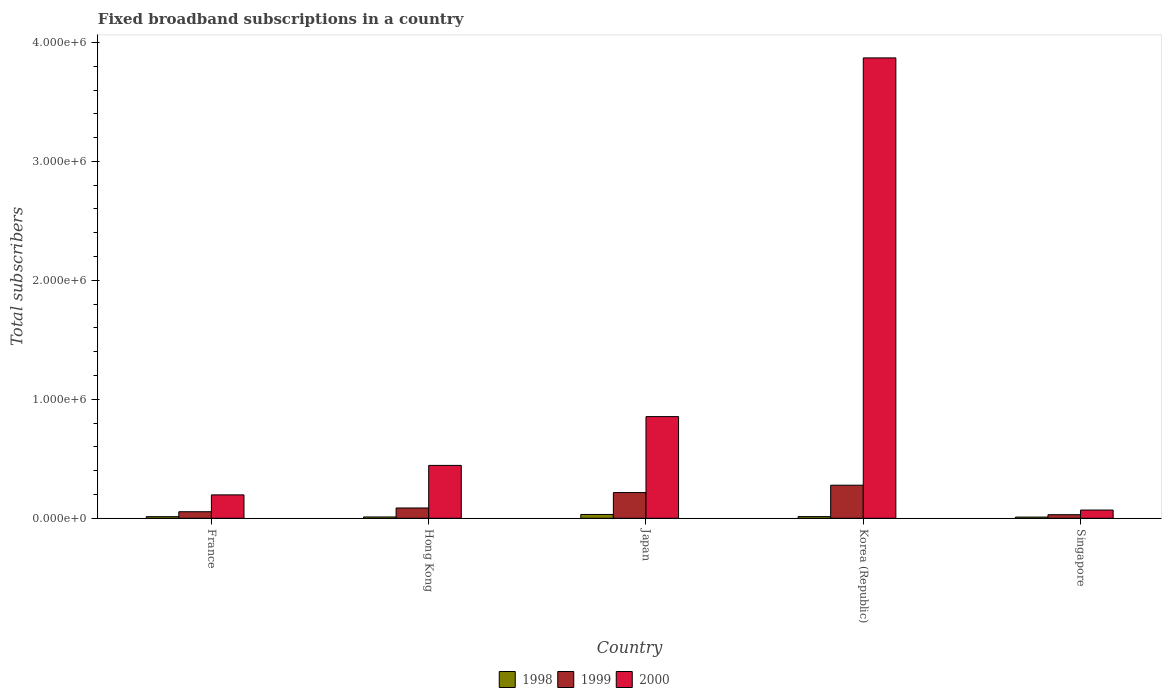How many groups of bars are there?
Keep it short and to the point. 5. In how many cases, is the number of bars for a given country not equal to the number of legend labels?
Offer a very short reply. 0. What is the number of broadband subscriptions in 1999 in France?
Your answer should be very brief. 5.50e+04. Across all countries, what is the maximum number of broadband subscriptions in 1998?
Your response must be concise. 3.20e+04. Across all countries, what is the minimum number of broadband subscriptions in 2000?
Ensure brevity in your answer.  6.90e+04. In which country was the number of broadband subscriptions in 1998 minimum?
Your response must be concise. Singapore. What is the total number of broadband subscriptions in 1999 in the graph?
Your answer should be very brief. 6.65e+05. What is the difference between the number of broadband subscriptions in 2000 in France and that in Singapore?
Provide a short and direct response. 1.28e+05. What is the difference between the number of broadband subscriptions in 2000 in Korea (Republic) and the number of broadband subscriptions in 1999 in Hong Kong?
Your answer should be compact. 3.78e+06. What is the average number of broadband subscriptions in 2000 per country?
Give a very brief answer. 1.09e+06. What is the difference between the number of broadband subscriptions of/in 2000 and number of broadband subscriptions of/in 1999 in Singapore?
Your answer should be very brief. 3.90e+04. What is the ratio of the number of broadband subscriptions in 1999 in Hong Kong to that in Korea (Republic)?
Offer a terse response. 0.31. What is the difference between the highest and the second highest number of broadband subscriptions in 1999?
Offer a very short reply. 1.92e+05. What is the difference between the highest and the lowest number of broadband subscriptions in 1998?
Keep it short and to the point. 2.20e+04. What does the 3rd bar from the left in France represents?
Provide a short and direct response. 2000. How many bars are there?
Offer a terse response. 15. Are all the bars in the graph horizontal?
Give a very brief answer. No. What is the difference between two consecutive major ticks on the Y-axis?
Your answer should be very brief. 1.00e+06. Are the values on the major ticks of Y-axis written in scientific E-notation?
Make the answer very short. Yes. Where does the legend appear in the graph?
Make the answer very short. Bottom center. What is the title of the graph?
Offer a very short reply. Fixed broadband subscriptions in a country. What is the label or title of the X-axis?
Your answer should be very brief. Country. What is the label or title of the Y-axis?
Ensure brevity in your answer.  Total subscribers. What is the Total subscribers of 1998 in France?
Provide a succinct answer. 1.35e+04. What is the Total subscribers in 1999 in France?
Your answer should be compact. 5.50e+04. What is the Total subscribers of 2000 in France?
Keep it short and to the point. 1.97e+05. What is the Total subscribers of 1998 in Hong Kong?
Provide a succinct answer. 1.10e+04. What is the Total subscribers in 1999 in Hong Kong?
Ensure brevity in your answer.  8.65e+04. What is the Total subscribers in 2000 in Hong Kong?
Your response must be concise. 4.44e+05. What is the Total subscribers in 1998 in Japan?
Provide a short and direct response. 3.20e+04. What is the Total subscribers of 1999 in Japan?
Give a very brief answer. 2.16e+05. What is the Total subscribers in 2000 in Japan?
Provide a short and direct response. 8.55e+05. What is the Total subscribers in 1998 in Korea (Republic)?
Offer a very short reply. 1.40e+04. What is the Total subscribers in 1999 in Korea (Republic)?
Give a very brief answer. 2.78e+05. What is the Total subscribers of 2000 in Korea (Republic)?
Make the answer very short. 3.87e+06. What is the Total subscribers of 2000 in Singapore?
Give a very brief answer. 6.90e+04. Across all countries, what is the maximum Total subscribers in 1998?
Ensure brevity in your answer.  3.20e+04. Across all countries, what is the maximum Total subscribers of 1999?
Keep it short and to the point. 2.78e+05. Across all countries, what is the maximum Total subscribers of 2000?
Provide a succinct answer. 3.87e+06. Across all countries, what is the minimum Total subscribers of 2000?
Your response must be concise. 6.90e+04. What is the total Total subscribers of 1998 in the graph?
Offer a terse response. 8.05e+04. What is the total Total subscribers in 1999 in the graph?
Your answer should be very brief. 6.65e+05. What is the total Total subscribers in 2000 in the graph?
Make the answer very short. 5.43e+06. What is the difference between the Total subscribers in 1998 in France and that in Hong Kong?
Provide a short and direct response. 2464. What is the difference between the Total subscribers of 1999 in France and that in Hong Kong?
Provide a succinct answer. -3.15e+04. What is the difference between the Total subscribers in 2000 in France and that in Hong Kong?
Make the answer very short. -2.48e+05. What is the difference between the Total subscribers in 1998 in France and that in Japan?
Your response must be concise. -1.85e+04. What is the difference between the Total subscribers in 1999 in France and that in Japan?
Provide a succinct answer. -1.61e+05. What is the difference between the Total subscribers in 2000 in France and that in Japan?
Provide a succinct answer. -6.58e+05. What is the difference between the Total subscribers of 1998 in France and that in Korea (Republic)?
Give a very brief answer. -536. What is the difference between the Total subscribers of 1999 in France and that in Korea (Republic)?
Your answer should be compact. -2.23e+05. What is the difference between the Total subscribers of 2000 in France and that in Korea (Republic)?
Keep it short and to the point. -3.67e+06. What is the difference between the Total subscribers in 1998 in France and that in Singapore?
Ensure brevity in your answer.  3464. What is the difference between the Total subscribers in 1999 in France and that in Singapore?
Give a very brief answer. 2.50e+04. What is the difference between the Total subscribers of 2000 in France and that in Singapore?
Provide a short and direct response. 1.28e+05. What is the difference between the Total subscribers of 1998 in Hong Kong and that in Japan?
Your answer should be compact. -2.10e+04. What is the difference between the Total subscribers of 1999 in Hong Kong and that in Japan?
Your answer should be compact. -1.30e+05. What is the difference between the Total subscribers of 2000 in Hong Kong and that in Japan?
Your response must be concise. -4.10e+05. What is the difference between the Total subscribers of 1998 in Hong Kong and that in Korea (Republic)?
Your answer should be compact. -3000. What is the difference between the Total subscribers of 1999 in Hong Kong and that in Korea (Republic)?
Your response must be concise. -1.92e+05. What is the difference between the Total subscribers in 2000 in Hong Kong and that in Korea (Republic)?
Provide a short and direct response. -3.43e+06. What is the difference between the Total subscribers in 1999 in Hong Kong and that in Singapore?
Keep it short and to the point. 5.65e+04. What is the difference between the Total subscribers in 2000 in Hong Kong and that in Singapore?
Keep it short and to the point. 3.75e+05. What is the difference between the Total subscribers in 1998 in Japan and that in Korea (Republic)?
Your response must be concise. 1.80e+04. What is the difference between the Total subscribers of 1999 in Japan and that in Korea (Republic)?
Give a very brief answer. -6.20e+04. What is the difference between the Total subscribers in 2000 in Japan and that in Korea (Republic)?
Keep it short and to the point. -3.02e+06. What is the difference between the Total subscribers in 1998 in Japan and that in Singapore?
Your answer should be compact. 2.20e+04. What is the difference between the Total subscribers of 1999 in Japan and that in Singapore?
Your answer should be very brief. 1.86e+05. What is the difference between the Total subscribers in 2000 in Japan and that in Singapore?
Your response must be concise. 7.86e+05. What is the difference between the Total subscribers in 1998 in Korea (Republic) and that in Singapore?
Provide a short and direct response. 4000. What is the difference between the Total subscribers of 1999 in Korea (Republic) and that in Singapore?
Offer a very short reply. 2.48e+05. What is the difference between the Total subscribers of 2000 in Korea (Republic) and that in Singapore?
Make the answer very short. 3.80e+06. What is the difference between the Total subscribers of 1998 in France and the Total subscribers of 1999 in Hong Kong?
Ensure brevity in your answer.  -7.30e+04. What is the difference between the Total subscribers of 1998 in France and the Total subscribers of 2000 in Hong Kong?
Provide a succinct answer. -4.31e+05. What is the difference between the Total subscribers of 1999 in France and the Total subscribers of 2000 in Hong Kong?
Offer a very short reply. -3.89e+05. What is the difference between the Total subscribers of 1998 in France and the Total subscribers of 1999 in Japan?
Your answer should be compact. -2.03e+05. What is the difference between the Total subscribers in 1998 in France and the Total subscribers in 2000 in Japan?
Your answer should be compact. -8.41e+05. What is the difference between the Total subscribers of 1999 in France and the Total subscribers of 2000 in Japan?
Give a very brief answer. -8.00e+05. What is the difference between the Total subscribers in 1998 in France and the Total subscribers in 1999 in Korea (Republic)?
Provide a succinct answer. -2.65e+05. What is the difference between the Total subscribers in 1998 in France and the Total subscribers in 2000 in Korea (Republic)?
Provide a short and direct response. -3.86e+06. What is the difference between the Total subscribers of 1999 in France and the Total subscribers of 2000 in Korea (Republic)?
Give a very brief answer. -3.82e+06. What is the difference between the Total subscribers of 1998 in France and the Total subscribers of 1999 in Singapore?
Keep it short and to the point. -1.65e+04. What is the difference between the Total subscribers of 1998 in France and the Total subscribers of 2000 in Singapore?
Your answer should be very brief. -5.55e+04. What is the difference between the Total subscribers of 1999 in France and the Total subscribers of 2000 in Singapore?
Keep it short and to the point. -1.40e+04. What is the difference between the Total subscribers in 1998 in Hong Kong and the Total subscribers in 1999 in Japan?
Ensure brevity in your answer.  -2.05e+05. What is the difference between the Total subscribers in 1998 in Hong Kong and the Total subscribers in 2000 in Japan?
Your answer should be compact. -8.44e+05. What is the difference between the Total subscribers in 1999 in Hong Kong and the Total subscribers in 2000 in Japan?
Offer a terse response. -7.68e+05. What is the difference between the Total subscribers of 1998 in Hong Kong and the Total subscribers of 1999 in Korea (Republic)?
Offer a terse response. -2.67e+05. What is the difference between the Total subscribers of 1998 in Hong Kong and the Total subscribers of 2000 in Korea (Republic)?
Ensure brevity in your answer.  -3.86e+06. What is the difference between the Total subscribers of 1999 in Hong Kong and the Total subscribers of 2000 in Korea (Republic)?
Your answer should be compact. -3.78e+06. What is the difference between the Total subscribers in 1998 in Hong Kong and the Total subscribers in 1999 in Singapore?
Provide a short and direct response. -1.90e+04. What is the difference between the Total subscribers in 1998 in Hong Kong and the Total subscribers in 2000 in Singapore?
Provide a short and direct response. -5.80e+04. What is the difference between the Total subscribers in 1999 in Hong Kong and the Total subscribers in 2000 in Singapore?
Provide a succinct answer. 1.75e+04. What is the difference between the Total subscribers in 1998 in Japan and the Total subscribers in 1999 in Korea (Republic)?
Your response must be concise. -2.46e+05. What is the difference between the Total subscribers in 1998 in Japan and the Total subscribers in 2000 in Korea (Republic)?
Your answer should be compact. -3.84e+06. What is the difference between the Total subscribers in 1999 in Japan and the Total subscribers in 2000 in Korea (Republic)?
Ensure brevity in your answer.  -3.65e+06. What is the difference between the Total subscribers of 1998 in Japan and the Total subscribers of 1999 in Singapore?
Offer a terse response. 2000. What is the difference between the Total subscribers in 1998 in Japan and the Total subscribers in 2000 in Singapore?
Your answer should be compact. -3.70e+04. What is the difference between the Total subscribers in 1999 in Japan and the Total subscribers in 2000 in Singapore?
Your answer should be very brief. 1.47e+05. What is the difference between the Total subscribers in 1998 in Korea (Republic) and the Total subscribers in 1999 in Singapore?
Offer a terse response. -1.60e+04. What is the difference between the Total subscribers in 1998 in Korea (Republic) and the Total subscribers in 2000 in Singapore?
Give a very brief answer. -5.50e+04. What is the difference between the Total subscribers of 1999 in Korea (Republic) and the Total subscribers of 2000 in Singapore?
Ensure brevity in your answer.  2.09e+05. What is the average Total subscribers in 1998 per country?
Give a very brief answer. 1.61e+04. What is the average Total subscribers of 1999 per country?
Your answer should be very brief. 1.33e+05. What is the average Total subscribers of 2000 per country?
Give a very brief answer. 1.09e+06. What is the difference between the Total subscribers in 1998 and Total subscribers in 1999 in France?
Keep it short and to the point. -4.15e+04. What is the difference between the Total subscribers of 1998 and Total subscribers of 2000 in France?
Provide a succinct answer. -1.83e+05. What is the difference between the Total subscribers of 1999 and Total subscribers of 2000 in France?
Provide a short and direct response. -1.42e+05. What is the difference between the Total subscribers in 1998 and Total subscribers in 1999 in Hong Kong?
Offer a terse response. -7.55e+04. What is the difference between the Total subscribers of 1998 and Total subscribers of 2000 in Hong Kong?
Provide a short and direct response. -4.33e+05. What is the difference between the Total subscribers in 1999 and Total subscribers in 2000 in Hong Kong?
Your answer should be very brief. -3.58e+05. What is the difference between the Total subscribers of 1998 and Total subscribers of 1999 in Japan?
Your response must be concise. -1.84e+05. What is the difference between the Total subscribers of 1998 and Total subscribers of 2000 in Japan?
Offer a terse response. -8.23e+05. What is the difference between the Total subscribers of 1999 and Total subscribers of 2000 in Japan?
Your answer should be very brief. -6.39e+05. What is the difference between the Total subscribers in 1998 and Total subscribers in 1999 in Korea (Republic)?
Offer a terse response. -2.64e+05. What is the difference between the Total subscribers of 1998 and Total subscribers of 2000 in Korea (Republic)?
Offer a very short reply. -3.86e+06. What is the difference between the Total subscribers of 1999 and Total subscribers of 2000 in Korea (Republic)?
Offer a very short reply. -3.59e+06. What is the difference between the Total subscribers of 1998 and Total subscribers of 1999 in Singapore?
Make the answer very short. -2.00e+04. What is the difference between the Total subscribers of 1998 and Total subscribers of 2000 in Singapore?
Your response must be concise. -5.90e+04. What is the difference between the Total subscribers in 1999 and Total subscribers in 2000 in Singapore?
Give a very brief answer. -3.90e+04. What is the ratio of the Total subscribers of 1998 in France to that in Hong Kong?
Keep it short and to the point. 1.22. What is the ratio of the Total subscribers of 1999 in France to that in Hong Kong?
Offer a very short reply. 0.64. What is the ratio of the Total subscribers in 2000 in France to that in Hong Kong?
Ensure brevity in your answer.  0.44. What is the ratio of the Total subscribers in 1998 in France to that in Japan?
Make the answer very short. 0.42. What is the ratio of the Total subscribers in 1999 in France to that in Japan?
Provide a short and direct response. 0.25. What is the ratio of the Total subscribers of 2000 in France to that in Japan?
Your response must be concise. 0.23. What is the ratio of the Total subscribers of 1998 in France to that in Korea (Republic)?
Keep it short and to the point. 0.96. What is the ratio of the Total subscribers in 1999 in France to that in Korea (Republic)?
Make the answer very short. 0.2. What is the ratio of the Total subscribers in 2000 in France to that in Korea (Republic)?
Your response must be concise. 0.05. What is the ratio of the Total subscribers in 1998 in France to that in Singapore?
Your response must be concise. 1.35. What is the ratio of the Total subscribers of 1999 in France to that in Singapore?
Make the answer very short. 1.83. What is the ratio of the Total subscribers in 2000 in France to that in Singapore?
Provide a succinct answer. 2.85. What is the ratio of the Total subscribers in 1998 in Hong Kong to that in Japan?
Make the answer very short. 0.34. What is the ratio of the Total subscribers in 1999 in Hong Kong to that in Japan?
Provide a short and direct response. 0.4. What is the ratio of the Total subscribers of 2000 in Hong Kong to that in Japan?
Offer a terse response. 0.52. What is the ratio of the Total subscribers of 1998 in Hong Kong to that in Korea (Republic)?
Offer a very short reply. 0.79. What is the ratio of the Total subscribers of 1999 in Hong Kong to that in Korea (Republic)?
Ensure brevity in your answer.  0.31. What is the ratio of the Total subscribers in 2000 in Hong Kong to that in Korea (Republic)?
Ensure brevity in your answer.  0.11. What is the ratio of the Total subscribers of 1999 in Hong Kong to that in Singapore?
Your response must be concise. 2.88. What is the ratio of the Total subscribers in 2000 in Hong Kong to that in Singapore?
Provide a short and direct response. 6.44. What is the ratio of the Total subscribers in 1998 in Japan to that in Korea (Republic)?
Make the answer very short. 2.29. What is the ratio of the Total subscribers of 1999 in Japan to that in Korea (Republic)?
Provide a succinct answer. 0.78. What is the ratio of the Total subscribers in 2000 in Japan to that in Korea (Republic)?
Ensure brevity in your answer.  0.22. What is the ratio of the Total subscribers in 1998 in Japan to that in Singapore?
Provide a short and direct response. 3.2. What is the ratio of the Total subscribers in 2000 in Japan to that in Singapore?
Offer a terse response. 12.39. What is the ratio of the Total subscribers of 1998 in Korea (Republic) to that in Singapore?
Provide a short and direct response. 1.4. What is the ratio of the Total subscribers in 1999 in Korea (Republic) to that in Singapore?
Offer a terse response. 9.27. What is the ratio of the Total subscribers in 2000 in Korea (Republic) to that in Singapore?
Offer a very short reply. 56.09. What is the difference between the highest and the second highest Total subscribers of 1998?
Your answer should be compact. 1.80e+04. What is the difference between the highest and the second highest Total subscribers of 1999?
Your answer should be very brief. 6.20e+04. What is the difference between the highest and the second highest Total subscribers of 2000?
Provide a short and direct response. 3.02e+06. What is the difference between the highest and the lowest Total subscribers of 1998?
Your answer should be very brief. 2.20e+04. What is the difference between the highest and the lowest Total subscribers in 1999?
Ensure brevity in your answer.  2.48e+05. What is the difference between the highest and the lowest Total subscribers of 2000?
Provide a short and direct response. 3.80e+06. 